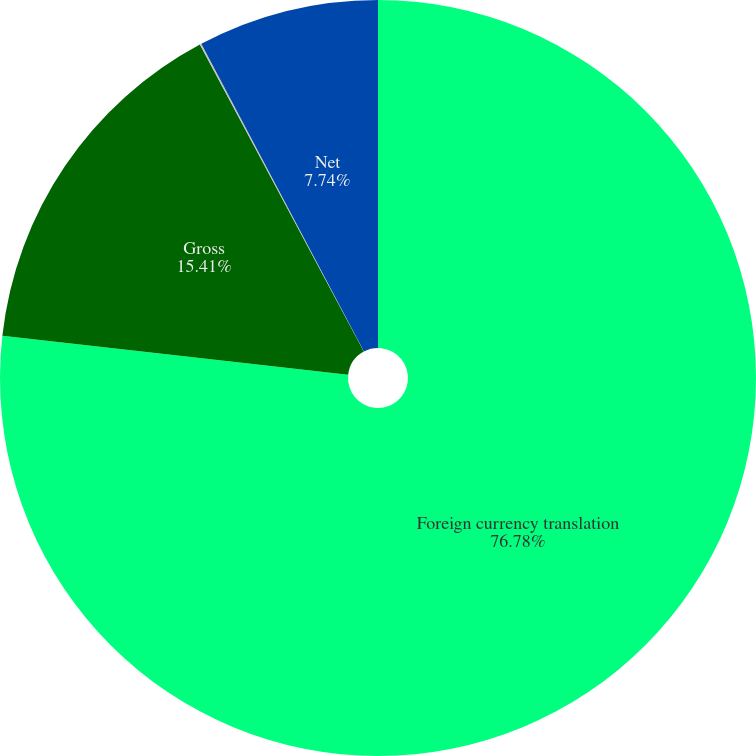Convert chart to OTSL. <chart><loc_0><loc_0><loc_500><loc_500><pie_chart><fcel>Foreign currency translation<fcel>Gross<fcel>Income tax (benefit)<fcel>Net<nl><fcel>76.77%<fcel>15.41%<fcel>0.07%<fcel>7.74%<nl></chart> 